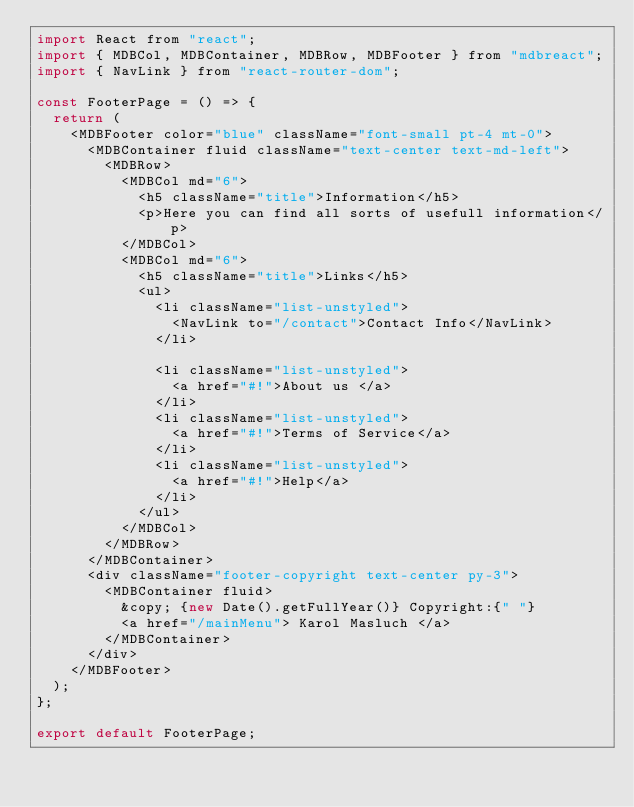<code> <loc_0><loc_0><loc_500><loc_500><_JavaScript_>import React from "react";
import { MDBCol, MDBContainer, MDBRow, MDBFooter } from "mdbreact";
import { NavLink } from "react-router-dom";

const FooterPage = () => {
  return (
    <MDBFooter color="blue" className="font-small pt-4 mt-0">
      <MDBContainer fluid className="text-center text-md-left">
        <MDBRow>
          <MDBCol md="6">
            <h5 className="title">Information</h5>
            <p>Here you can find all sorts of usefull information</p>
          </MDBCol>
          <MDBCol md="6">
            <h5 className="title">Links</h5>
            <ul>
              <li className="list-unstyled">
                <NavLink to="/contact">Contact Info</NavLink>
              </li>

              <li className="list-unstyled">
                <a href="#!">About us </a>
              </li>
              <li className="list-unstyled">
                <a href="#!">Terms of Service</a>
              </li>
              <li className="list-unstyled">
                <a href="#!">Help</a>
              </li>
            </ul>
          </MDBCol>
        </MDBRow>
      </MDBContainer>
      <div className="footer-copyright text-center py-3">
        <MDBContainer fluid>
          &copy; {new Date().getFullYear()} Copyright:{" "}
          <a href="/mainMenu"> Karol Masluch </a>
        </MDBContainer>
      </div>
    </MDBFooter>
  );
};

export default FooterPage;
</code> 